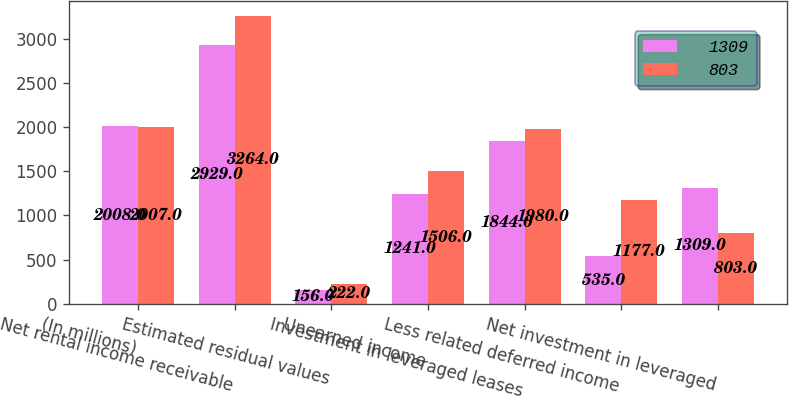Convert chart to OTSL. <chart><loc_0><loc_0><loc_500><loc_500><stacked_bar_chart><ecel><fcel>(In millions)<fcel>Net rental income receivable<fcel>Estimated residual values<fcel>Unearned income<fcel>Investment in leveraged leases<fcel>Less related deferred income<fcel>Net investment in leveraged<nl><fcel>1309<fcel>2008<fcel>2929<fcel>156<fcel>1241<fcel>1844<fcel>535<fcel>1309<nl><fcel>803<fcel>2007<fcel>3264<fcel>222<fcel>1506<fcel>1980<fcel>1177<fcel>803<nl></chart> 